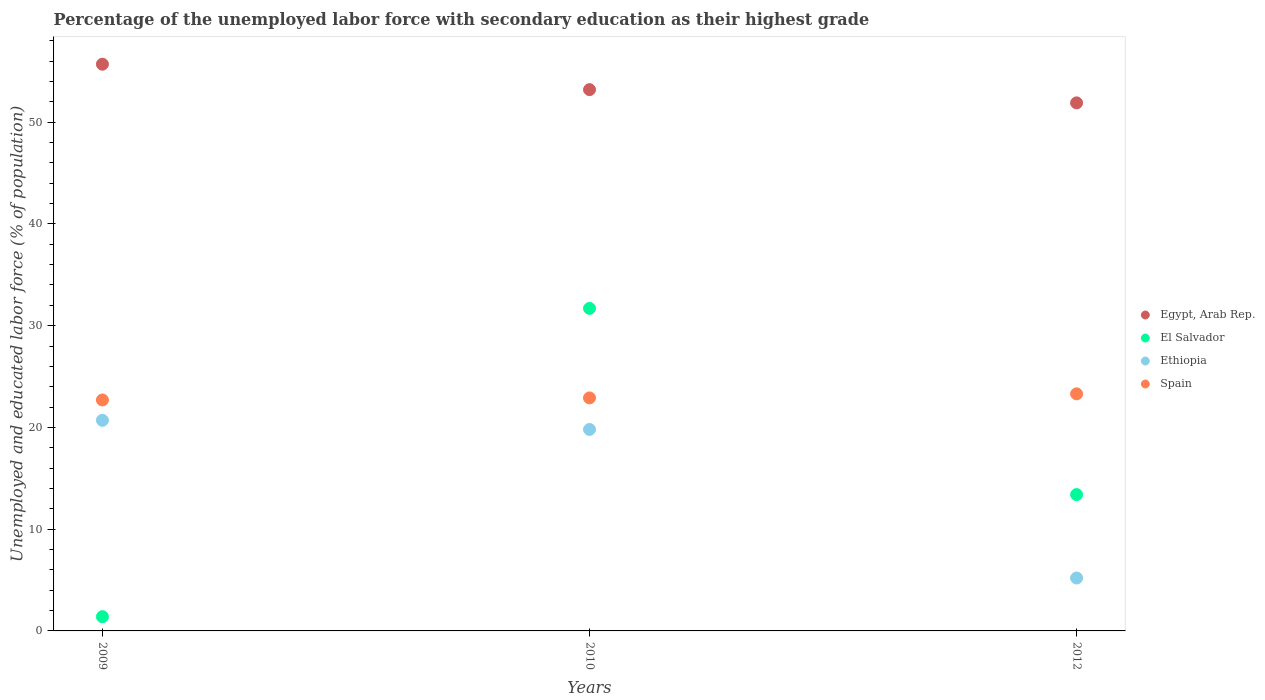How many different coloured dotlines are there?
Offer a very short reply. 4. Is the number of dotlines equal to the number of legend labels?
Ensure brevity in your answer.  Yes. What is the percentage of the unemployed labor force with secondary education in Ethiopia in 2009?
Give a very brief answer. 20.7. Across all years, what is the maximum percentage of the unemployed labor force with secondary education in Ethiopia?
Offer a very short reply. 20.7. Across all years, what is the minimum percentage of the unemployed labor force with secondary education in Ethiopia?
Give a very brief answer. 5.2. In which year was the percentage of the unemployed labor force with secondary education in Egypt, Arab Rep. maximum?
Give a very brief answer. 2009. What is the total percentage of the unemployed labor force with secondary education in Ethiopia in the graph?
Ensure brevity in your answer.  45.7. What is the difference between the percentage of the unemployed labor force with secondary education in Ethiopia in 2010 and that in 2012?
Provide a succinct answer. 14.6. What is the difference between the percentage of the unemployed labor force with secondary education in El Salvador in 2012 and the percentage of the unemployed labor force with secondary education in Egypt, Arab Rep. in 2010?
Provide a succinct answer. -39.8. What is the average percentage of the unemployed labor force with secondary education in Egypt, Arab Rep. per year?
Ensure brevity in your answer.  53.6. In the year 2009, what is the difference between the percentage of the unemployed labor force with secondary education in Spain and percentage of the unemployed labor force with secondary education in Egypt, Arab Rep.?
Offer a terse response. -33. In how many years, is the percentage of the unemployed labor force with secondary education in El Salvador greater than 24 %?
Make the answer very short. 1. What is the ratio of the percentage of the unemployed labor force with secondary education in Egypt, Arab Rep. in 2009 to that in 2012?
Give a very brief answer. 1.07. What is the difference between the highest and the second highest percentage of the unemployed labor force with secondary education in El Salvador?
Your answer should be very brief. 18.3. What is the difference between the highest and the lowest percentage of the unemployed labor force with secondary education in El Salvador?
Make the answer very short. 30.3. In how many years, is the percentage of the unemployed labor force with secondary education in El Salvador greater than the average percentage of the unemployed labor force with secondary education in El Salvador taken over all years?
Your response must be concise. 1. Is it the case that in every year, the sum of the percentage of the unemployed labor force with secondary education in Ethiopia and percentage of the unemployed labor force with secondary education in Spain  is greater than the sum of percentage of the unemployed labor force with secondary education in El Salvador and percentage of the unemployed labor force with secondary education in Egypt, Arab Rep.?
Offer a very short reply. No. Is the percentage of the unemployed labor force with secondary education in Spain strictly less than the percentage of the unemployed labor force with secondary education in Ethiopia over the years?
Provide a succinct answer. No. What is the difference between two consecutive major ticks on the Y-axis?
Offer a very short reply. 10. Are the values on the major ticks of Y-axis written in scientific E-notation?
Offer a terse response. No. Where does the legend appear in the graph?
Provide a short and direct response. Center right. How many legend labels are there?
Provide a succinct answer. 4. How are the legend labels stacked?
Provide a succinct answer. Vertical. What is the title of the graph?
Provide a succinct answer. Percentage of the unemployed labor force with secondary education as their highest grade. What is the label or title of the X-axis?
Make the answer very short. Years. What is the label or title of the Y-axis?
Your response must be concise. Unemployed and educated labor force (% of population). What is the Unemployed and educated labor force (% of population) of Egypt, Arab Rep. in 2009?
Provide a succinct answer. 55.7. What is the Unemployed and educated labor force (% of population) in El Salvador in 2009?
Your answer should be compact. 1.4. What is the Unemployed and educated labor force (% of population) of Ethiopia in 2009?
Ensure brevity in your answer.  20.7. What is the Unemployed and educated labor force (% of population) in Spain in 2009?
Offer a terse response. 22.7. What is the Unemployed and educated labor force (% of population) of Egypt, Arab Rep. in 2010?
Offer a very short reply. 53.2. What is the Unemployed and educated labor force (% of population) of El Salvador in 2010?
Offer a terse response. 31.7. What is the Unemployed and educated labor force (% of population) in Ethiopia in 2010?
Give a very brief answer. 19.8. What is the Unemployed and educated labor force (% of population) in Spain in 2010?
Your response must be concise. 22.9. What is the Unemployed and educated labor force (% of population) in Egypt, Arab Rep. in 2012?
Ensure brevity in your answer.  51.9. What is the Unemployed and educated labor force (% of population) in El Salvador in 2012?
Ensure brevity in your answer.  13.4. What is the Unemployed and educated labor force (% of population) of Ethiopia in 2012?
Offer a very short reply. 5.2. What is the Unemployed and educated labor force (% of population) in Spain in 2012?
Make the answer very short. 23.3. Across all years, what is the maximum Unemployed and educated labor force (% of population) of Egypt, Arab Rep.?
Offer a very short reply. 55.7. Across all years, what is the maximum Unemployed and educated labor force (% of population) in El Salvador?
Offer a very short reply. 31.7. Across all years, what is the maximum Unemployed and educated labor force (% of population) of Ethiopia?
Your response must be concise. 20.7. Across all years, what is the maximum Unemployed and educated labor force (% of population) of Spain?
Offer a terse response. 23.3. Across all years, what is the minimum Unemployed and educated labor force (% of population) of Egypt, Arab Rep.?
Provide a short and direct response. 51.9. Across all years, what is the minimum Unemployed and educated labor force (% of population) of El Salvador?
Your answer should be very brief. 1.4. Across all years, what is the minimum Unemployed and educated labor force (% of population) in Ethiopia?
Offer a very short reply. 5.2. Across all years, what is the minimum Unemployed and educated labor force (% of population) of Spain?
Offer a terse response. 22.7. What is the total Unemployed and educated labor force (% of population) in Egypt, Arab Rep. in the graph?
Make the answer very short. 160.8. What is the total Unemployed and educated labor force (% of population) in El Salvador in the graph?
Provide a short and direct response. 46.5. What is the total Unemployed and educated labor force (% of population) in Ethiopia in the graph?
Give a very brief answer. 45.7. What is the total Unemployed and educated labor force (% of population) in Spain in the graph?
Ensure brevity in your answer.  68.9. What is the difference between the Unemployed and educated labor force (% of population) of Egypt, Arab Rep. in 2009 and that in 2010?
Offer a terse response. 2.5. What is the difference between the Unemployed and educated labor force (% of population) in El Salvador in 2009 and that in 2010?
Offer a terse response. -30.3. What is the difference between the Unemployed and educated labor force (% of population) of Ethiopia in 2009 and that in 2010?
Your response must be concise. 0.9. What is the difference between the Unemployed and educated labor force (% of population) in Ethiopia in 2009 and that in 2012?
Offer a very short reply. 15.5. What is the difference between the Unemployed and educated labor force (% of population) of Spain in 2009 and that in 2012?
Your answer should be compact. -0.6. What is the difference between the Unemployed and educated labor force (% of population) of Egypt, Arab Rep. in 2010 and that in 2012?
Offer a terse response. 1.3. What is the difference between the Unemployed and educated labor force (% of population) in El Salvador in 2010 and that in 2012?
Provide a succinct answer. 18.3. What is the difference between the Unemployed and educated labor force (% of population) of Egypt, Arab Rep. in 2009 and the Unemployed and educated labor force (% of population) of El Salvador in 2010?
Your answer should be compact. 24. What is the difference between the Unemployed and educated labor force (% of population) of Egypt, Arab Rep. in 2009 and the Unemployed and educated labor force (% of population) of Ethiopia in 2010?
Your answer should be compact. 35.9. What is the difference between the Unemployed and educated labor force (% of population) of Egypt, Arab Rep. in 2009 and the Unemployed and educated labor force (% of population) of Spain in 2010?
Make the answer very short. 32.8. What is the difference between the Unemployed and educated labor force (% of population) of El Salvador in 2009 and the Unemployed and educated labor force (% of population) of Ethiopia in 2010?
Offer a terse response. -18.4. What is the difference between the Unemployed and educated labor force (% of population) of El Salvador in 2009 and the Unemployed and educated labor force (% of population) of Spain in 2010?
Offer a very short reply. -21.5. What is the difference between the Unemployed and educated labor force (% of population) of Egypt, Arab Rep. in 2009 and the Unemployed and educated labor force (% of population) of El Salvador in 2012?
Offer a terse response. 42.3. What is the difference between the Unemployed and educated labor force (% of population) of Egypt, Arab Rep. in 2009 and the Unemployed and educated labor force (% of population) of Ethiopia in 2012?
Provide a succinct answer. 50.5. What is the difference between the Unemployed and educated labor force (% of population) of Egypt, Arab Rep. in 2009 and the Unemployed and educated labor force (% of population) of Spain in 2012?
Provide a succinct answer. 32.4. What is the difference between the Unemployed and educated labor force (% of population) in El Salvador in 2009 and the Unemployed and educated labor force (% of population) in Spain in 2012?
Provide a short and direct response. -21.9. What is the difference between the Unemployed and educated labor force (% of population) in Egypt, Arab Rep. in 2010 and the Unemployed and educated labor force (% of population) in El Salvador in 2012?
Keep it short and to the point. 39.8. What is the difference between the Unemployed and educated labor force (% of population) of Egypt, Arab Rep. in 2010 and the Unemployed and educated labor force (% of population) of Spain in 2012?
Ensure brevity in your answer.  29.9. What is the difference between the Unemployed and educated labor force (% of population) of El Salvador in 2010 and the Unemployed and educated labor force (% of population) of Ethiopia in 2012?
Offer a terse response. 26.5. What is the difference between the Unemployed and educated labor force (% of population) in El Salvador in 2010 and the Unemployed and educated labor force (% of population) in Spain in 2012?
Your answer should be very brief. 8.4. What is the average Unemployed and educated labor force (% of population) in Egypt, Arab Rep. per year?
Offer a terse response. 53.6. What is the average Unemployed and educated labor force (% of population) in El Salvador per year?
Offer a terse response. 15.5. What is the average Unemployed and educated labor force (% of population) in Ethiopia per year?
Offer a terse response. 15.23. What is the average Unemployed and educated labor force (% of population) in Spain per year?
Your answer should be very brief. 22.97. In the year 2009, what is the difference between the Unemployed and educated labor force (% of population) in Egypt, Arab Rep. and Unemployed and educated labor force (% of population) in El Salvador?
Your answer should be very brief. 54.3. In the year 2009, what is the difference between the Unemployed and educated labor force (% of population) of El Salvador and Unemployed and educated labor force (% of population) of Ethiopia?
Provide a short and direct response. -19.3. In the year 2009, what is the difference between the Unemployed and educated labor force (% of population) of El Salvador and Unemployed and educated labor force (% of population) of Spain?
Provide a succinct answer. -21.3. In the year 2009, what is the difference between the Unemployed and educated labor force (% of population) of Ethiopia and Unemployed and educated labor force (% of population) of Spain?
Ensure brevity in your answer.  -2. In the year 2010, what is the difference between the Unemployed and educated labor force (% of population) of Egypt, Arab Rep. and Unemployed and educated labor force (% of population) of Ethiopia?
Offer a very short reply. 33.4. In the year 2010, what is the difference between the Unemployed and educated labor force (% of population) in Egypt, Arab Rep. and Unemployed and educated labor force (% of population) in Spain?
Your answer should be very brief. 30.3. In the year 2010, what is the difference between the Unemployed and educated labor force (% of population) in El Salvador and Unemployed and educated labor force (% of population) in Ethiopia?
Your answer should be very brief. 11.9. In the year 2012, what is the difference between the Unemployed and educated labor force (% of population) in Egypt, Arab Rep. and Unemployed and educated labor force (% of population) in El Salvador?
Offer a terse response. 38.5. In the year 2012, what is the difference between the Unemployed and educated labor force (% of population) in Egypt, Arab Rep. and Unemployed and educated labor force (% of population) in Ethiopia?
Your answer should be very brief. 46.7. In the year 2012, what is the difference between the Unemployed and educated labor force (% of population) of Egypt, Arab Rep. and Unemployed and educated labor force (% of population) of Spain?
Offer a very short reply. 28.6. In the year 2012, what is the difference between the Unemployed and educated labor force (% of population) in El Salvador and Unemployed and educated labor force (% of population) in Ethiopia?
Make the answer very short. 8.2. In the year 2012, what is the difference between the Unemployed and educated labor force (% of population) of Ethiopia and Unemployed and educated labor force (% of population) of Spain?
Keep it short and to the point. -18.1. What is the ratio of the Unemployed and educated labor force (% of population) of Egypt, Arab Rep. in 2009 to that in 2010?
Give a very brief answer. 1.05. What is the ratio of the Unemployed and educated labor force (% of population) of El Salvador in 2009 to that in 2010?
Provide a succinct answer. 0.04. What is the ratio of the Unemployed and educated labor force (% of population) of Ethiopia in 2009 to that in 2010?
Offer a very short reply. 1.05. What is the ratio of the Unemployed and educated labor force (% of population) in Egypt, Arab Rep. in 2009 to that in 2012?
Your response must be concise. 1.07. What is the ratio of the Unemployed and educated labor force (% of population) of El Salvador in 2009 to that in 2012?
Your answer should be compact. 0.1. What is the ratio of the Unemployed and educated labor force (% of population) of Ethiopia in 2009 to that in 2012?
Keep it short and to the point. 3.98. What is the ratio of the Unemployed and educated labor force (% of population) of Spain in 2009 to that in 2012?
Offer a terse response. 0.97. What is the ratio of the Unemployed and educated labor force (% of population) of El Salvador in 2010 to that in 2012?
Offer a terse response. 2.37. What is the ratio of the Unemployed and educated labor force (% of population) of Ethiopia in 2010 to that in 2012?
Ensure brevity in your answer.  3.81. What is the ratio of the Unemployed and educated labor force (% of population) in Spain in 2010 to that in 2012?
Your response must be concise. 0.98. What is the difference between the highest and the second highest Unemployed and educated labor force (% of population) in El Salvador?
Your answer should be compact. 18.3. What is the difference between the highest and the second highest Unemployed and educated labor force (% of population) in Ethiopia?
Offer a very short reply. 0.9. What is the difference between the highest and the lowest Unemployed and educated labor force (% of population) of El Salvador?
Offer a very short reply. 30.3. What is the difference between the highest and the lowest Unemployed and educated labor force (% of population) in Ethiopia?
Give a very brief answer. 15.5. What is the difference between the highest and the lowest Unemployed and educated labor force (% of population) of Spain?
Make the answer very short. 0.6. 